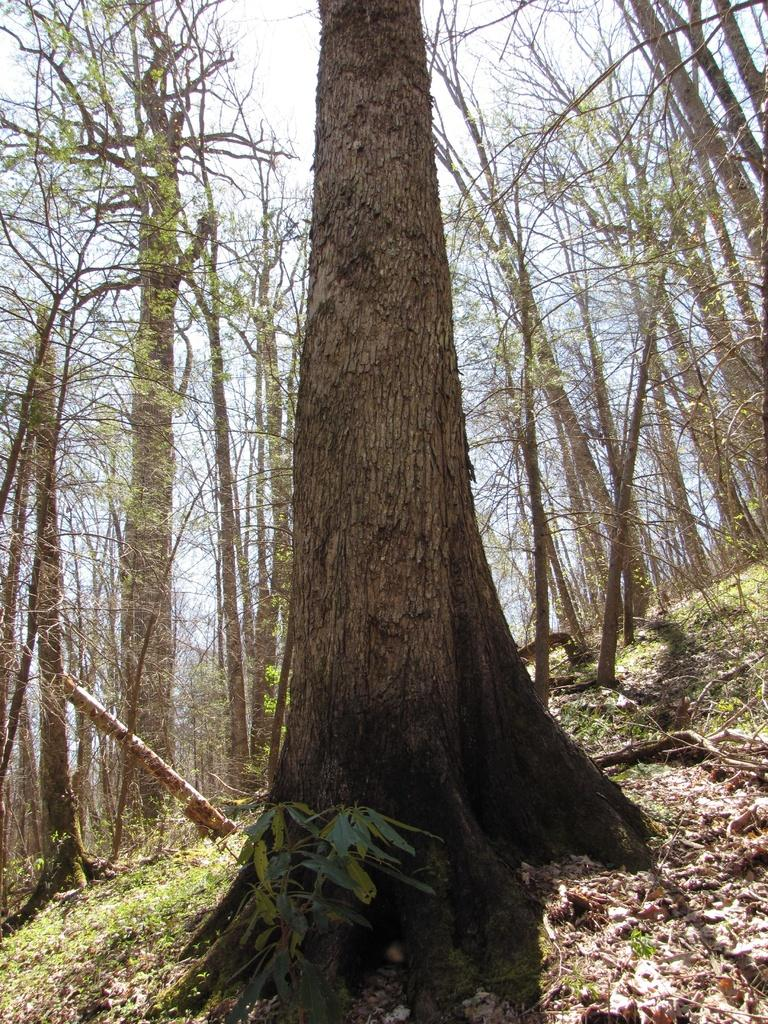What type of vegetation can be seen in the image? There are trees in the image. What is visible in the background of the image? The sky is visible in the background of the image. What is the reaction of the trees to the sudden change in weather in the image? There is no indication of a sudden change in weather in the image, and trees do not have reactions. 